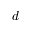<formula> <loc_0><loc_0><loc_500><loc_500>d</formula> 